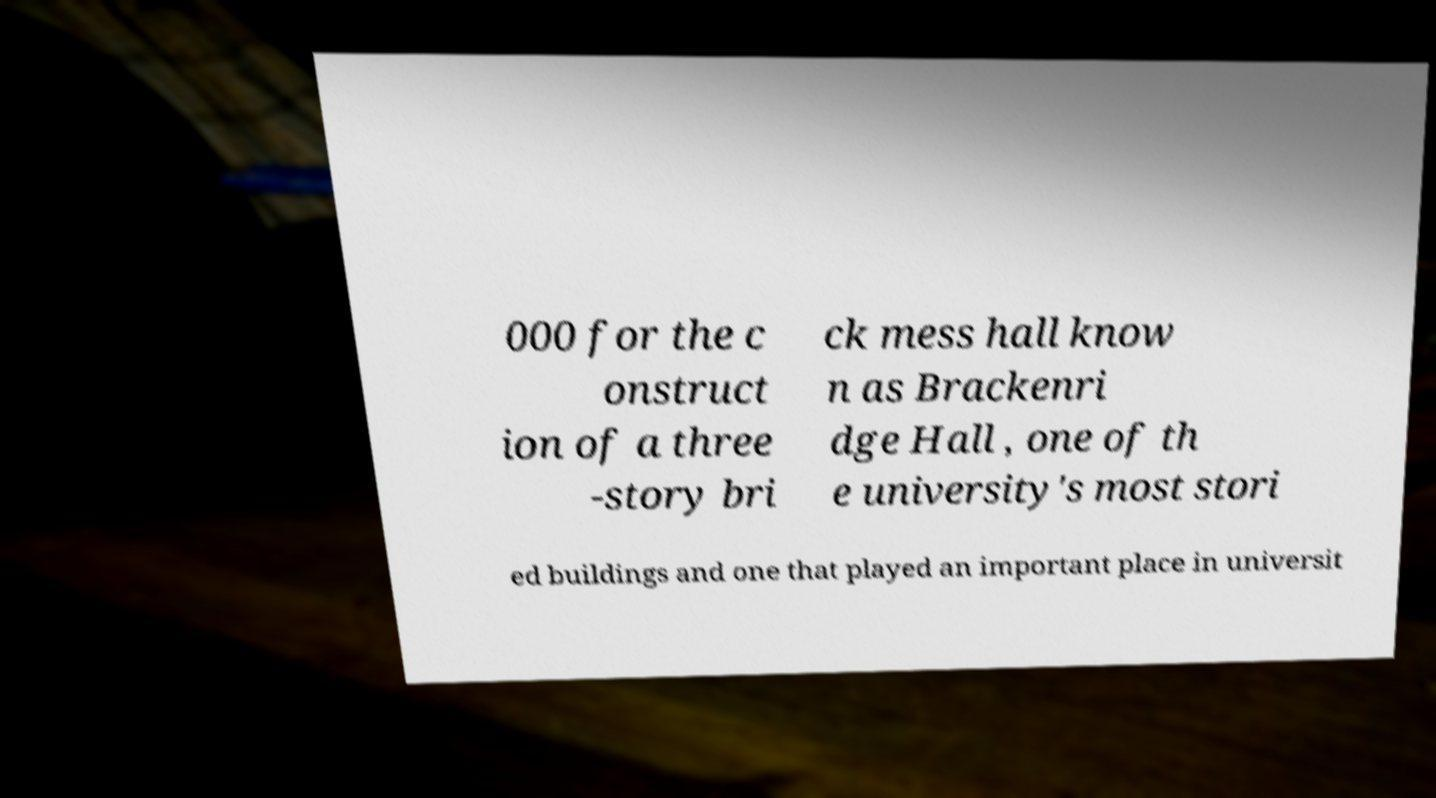What messages or text are displayed in this image? I need them in a readable, typed format. 000 for the c onstruct ion of a three -story bri ck mess hall know n as Brackenri dge Hall , one of th e university's most stori ed buildings and one that played an important place in universit 